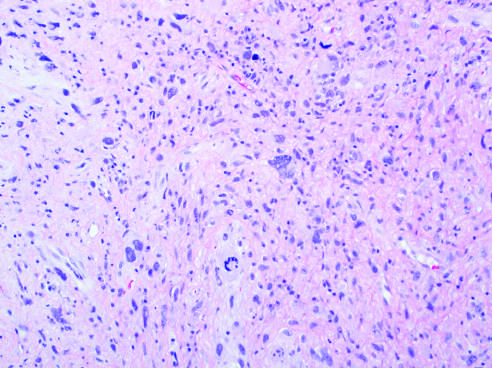does undifferentiated pleomorphic sarcoma show anaplastic spindled to polygonal cells?
Answer the question using a single word or phrase. Yes 